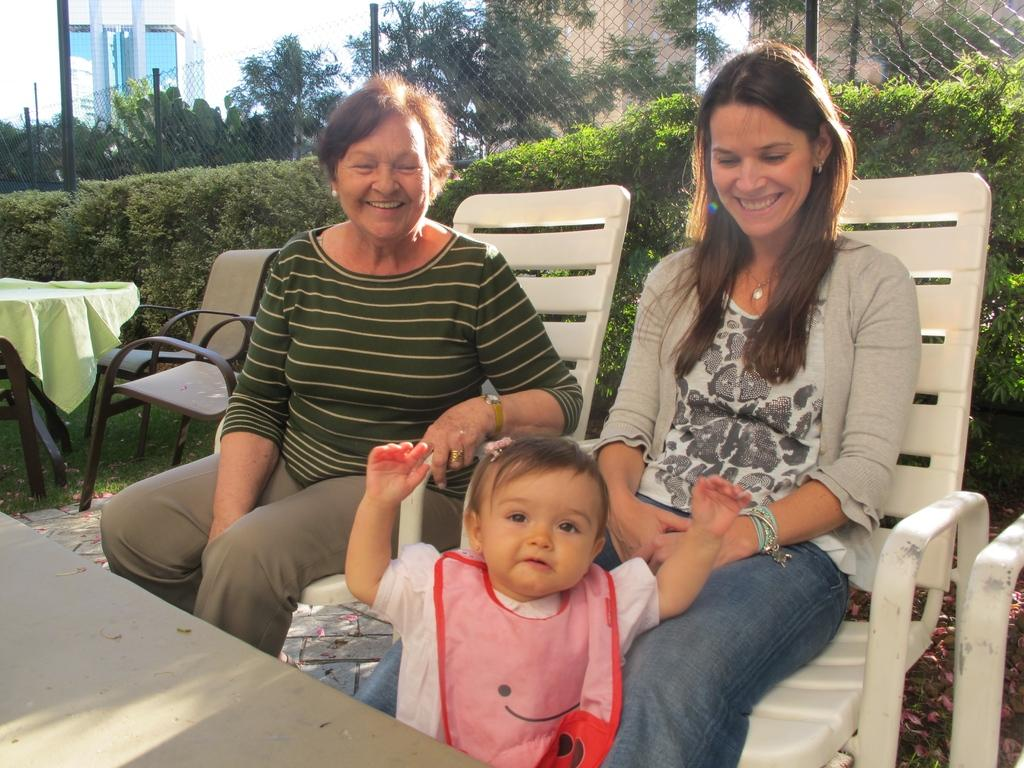Where was the image taken? The image is taken outdoors. What is the weather like in the image? It is sunny in the image. How many women are in the image? There are two women in the image. What are the women doing in the image? The women are sitting on a chair and looking at a baby. What can be seen behind the people in the image? There are bushes and fencing behind the people, as well as a building in the background. What type of lamp is hanging from the tree in the image? There is no lamp present in the image; it is taken outdoors with no visible lamps. 